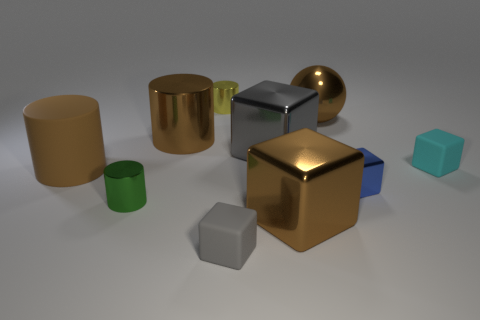What is the size of the rubber thing to the right of the brown thing that is right of the big brown cube?
Give a very brief answer. Small. There is a brown sphere; how many brown matte objects are behind it?
Make the answer very short. 0. What is the shape of the metallic thing that is both behind the tiny green cylinder and to the left of the small yellow metal cylinder?
Make the answer very short. Cylinder. What is the material of the other cylinder that is the same color as the big rubber cylinder?
Your answer should be very brief. Metal. How many cylinders are tiny green metal objects or large blue objects?
Your answer should be compact. 1. There is a rubber thing that is the same color as the large ball; what is its size?
Offer a very short reply. Large. Is the number of cyan objects that are behind the big metallic ball less than the number of small gray matte objects?
Give a very brief answer. Yes. There is a cube that is to the right of the ball and behind the tiny shiny block; what color is it?
Your answer should be very brief. Cyan. How many other things are the same shape as the small yellow object?
Make the answer very short. 3. Are there fewer blue objects that are on the right side of the cyan matte block than large gray cubes that are on the left side of the small gray block?
Provide a succinct answer. No. 